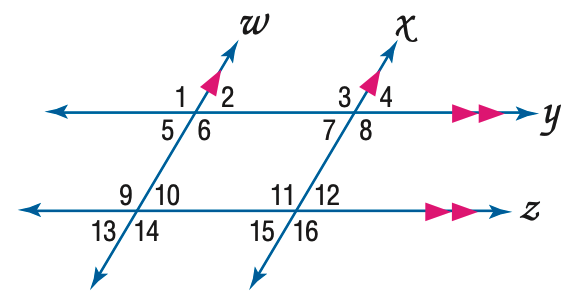Answer the mathemtical geometry problem and directly provide the correct option letter.
Question: In the figure, m \angle 12 = 64. Find the measure of \angle 11.
Choices: A: 104 B: 106 C: 114 D: 116 D 